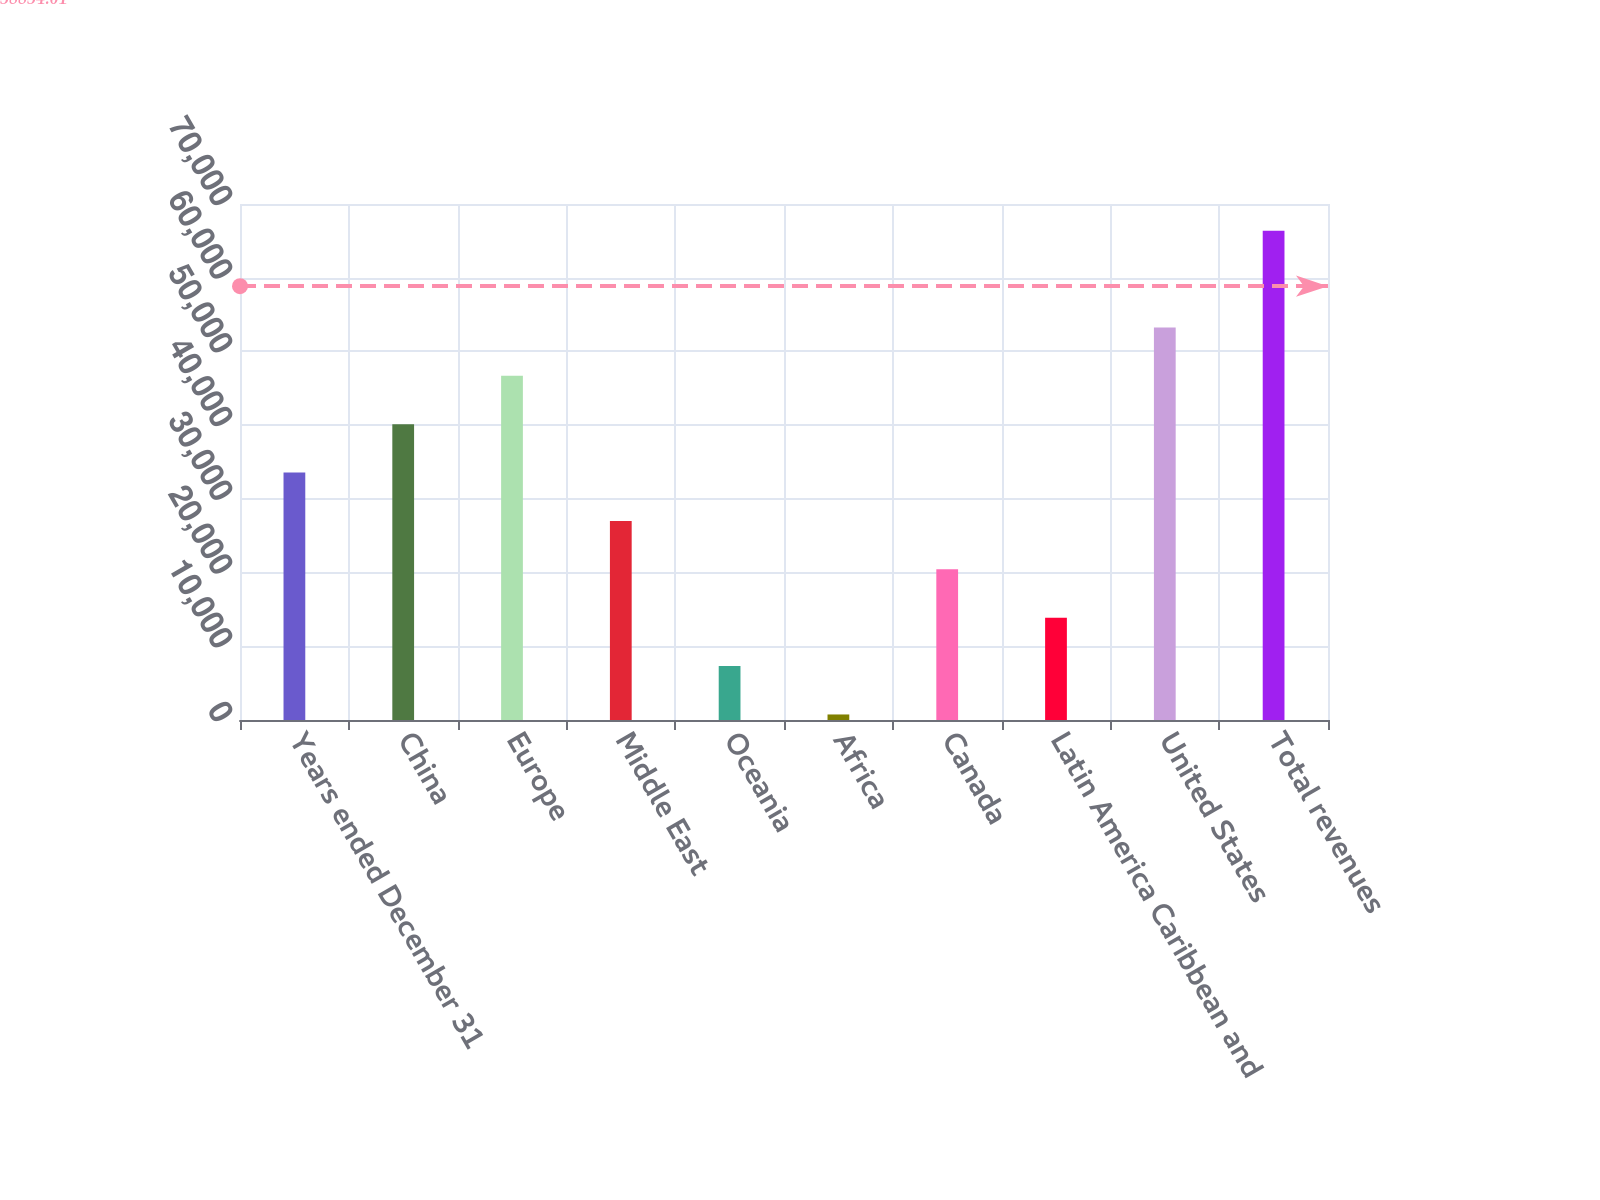<chart> <loc_0><loc_0><loc_500><loc_500><bar_chart><fcel>Years ended December 31<fcel>China<fcel>Europe<fcel>Middle East<fcel>Oceania<fcel>Africa<fcel>Canada<fcel>Latin America Caribbean and<fcel>United States<fcel>Total revenues<nl><fcel>33569<fcel>40132.6<fcel>46696.2<fcel>27005.4<fcel>7314.6<fcel>751<fcel>20441.8<fcel>13878.2<fcel>53259.8<fcel>66387<nl></chart> 